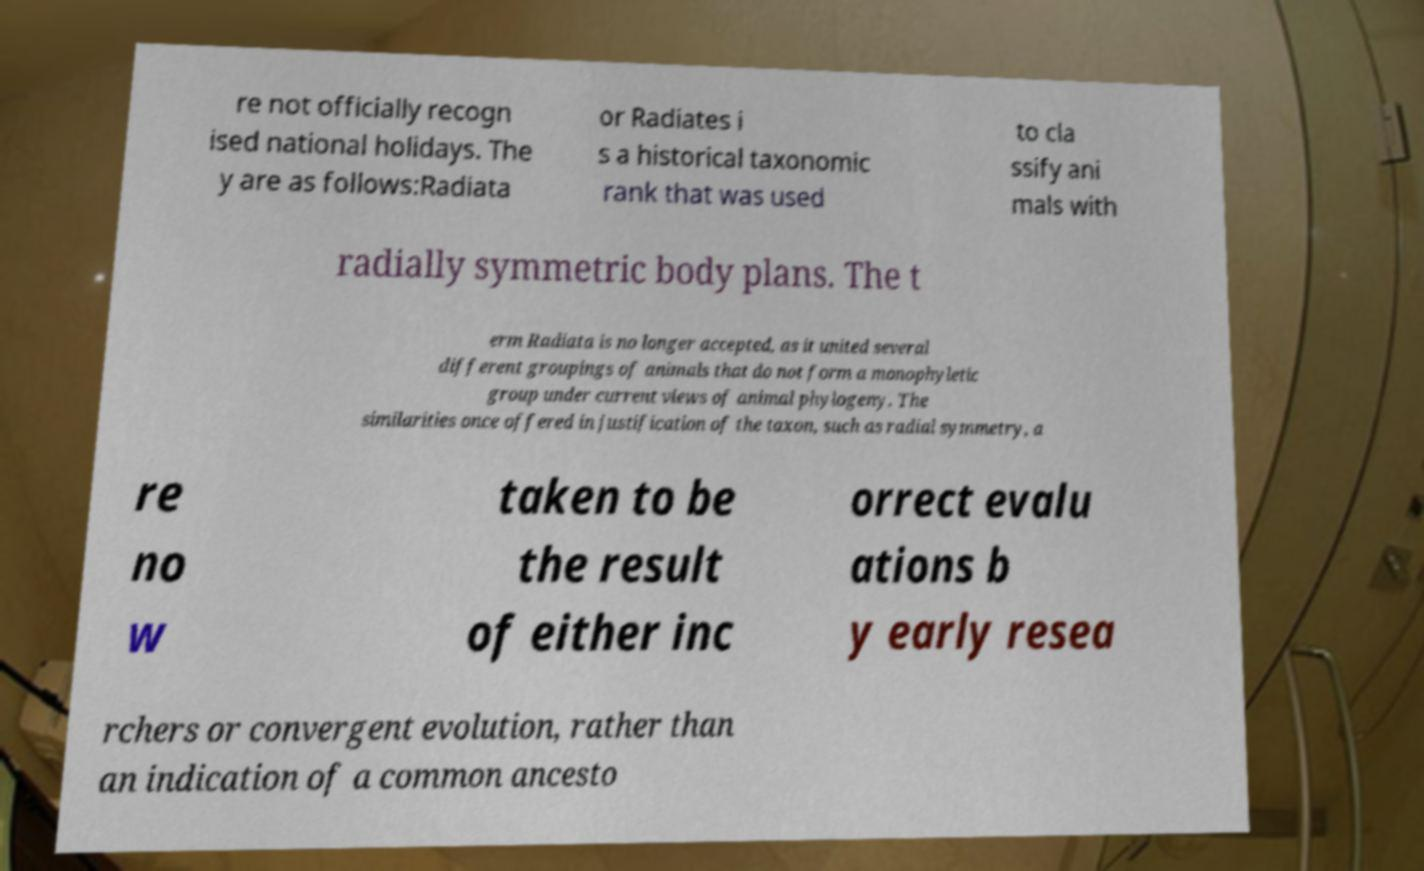There's text embedded in this image that I need extracted. Can you transcribe it verbatim? re not officially recogn ised national holidays. The y are as follows:Radiata or Radiates i s a historical taxonomic rank that was used to cla ssify ani mals with radially symmetric body plans. The t erm Radiata is no longer accepted, as it united several different groupings of animals that do not form a monophyletic group under current views of animal phylogeny. The similarities once offered in justification of the taxon, such as radial symmetry, a re no w taken to be the result of either inc orrect evalu ations b y early resea rchers or convergent evolution, rather than an indication of a common ancesto 